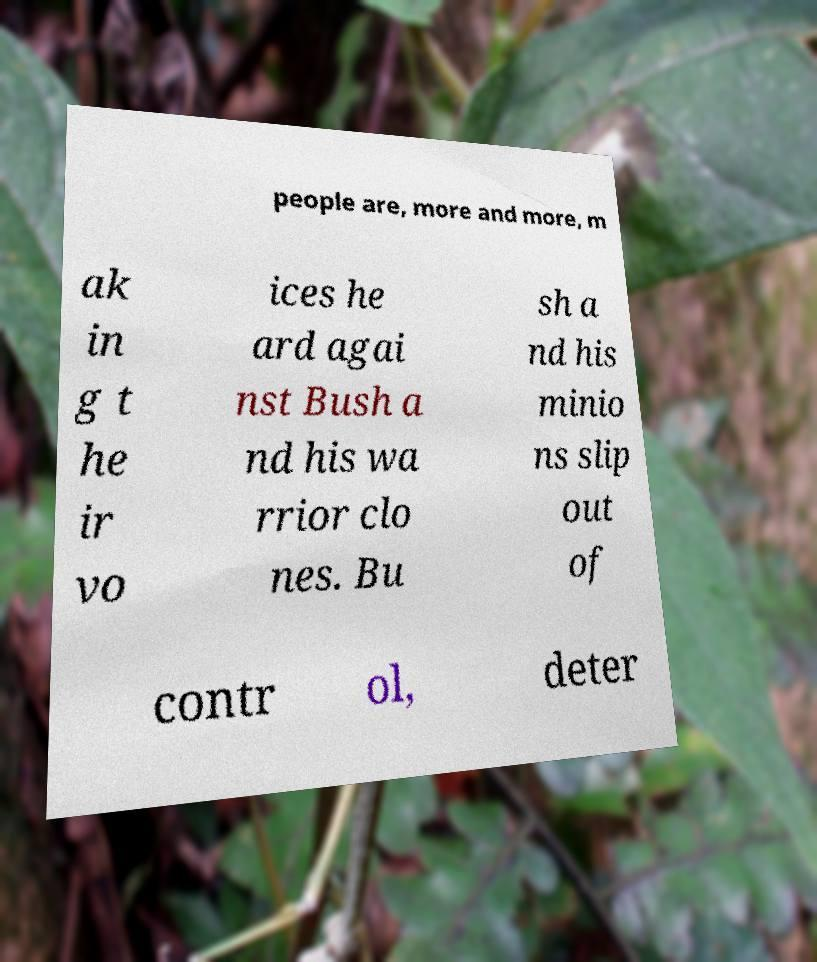I need the written content from this picture converted into text. Can you do that? people are, more and more, m ak in g t he ir vo ices he ard agai nst Bush a nd his wa rrior clo nes. Bu sh a nd his minio ns slip out of contr ol, deter 